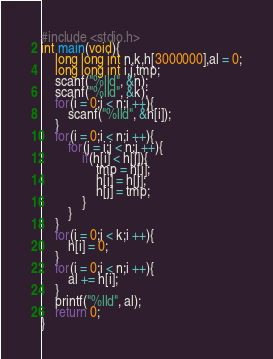<code> <loc_0><loc_0><loc_500><loc_500><_C_>#include <stdio.h>
int main(void){
    long long int n,k,h[3000000],al = 0;
    long long int i,j,tmp;
    scanf("%lld", &n);
    scanf("%lld", &k);
    for(i = 0;i < n;i ++){
        scanf("%lld", &h[i]);
    }
    for(i = 0;i < n;i ++){
        for(j = i;j < n;j ++){
            if(h[i] < h[j]){
                tmp = h[i];
                h[i] = h[j];
                h[j] = tmp;
            }
        }
    }
    for(i = 0;i < k;i ++){
        h[i] = 0;
    }
    for(i = 0;i < n;i ++){
        al += h[i];
    }
    printf("%lld", al);
    return 0;
}</code> 